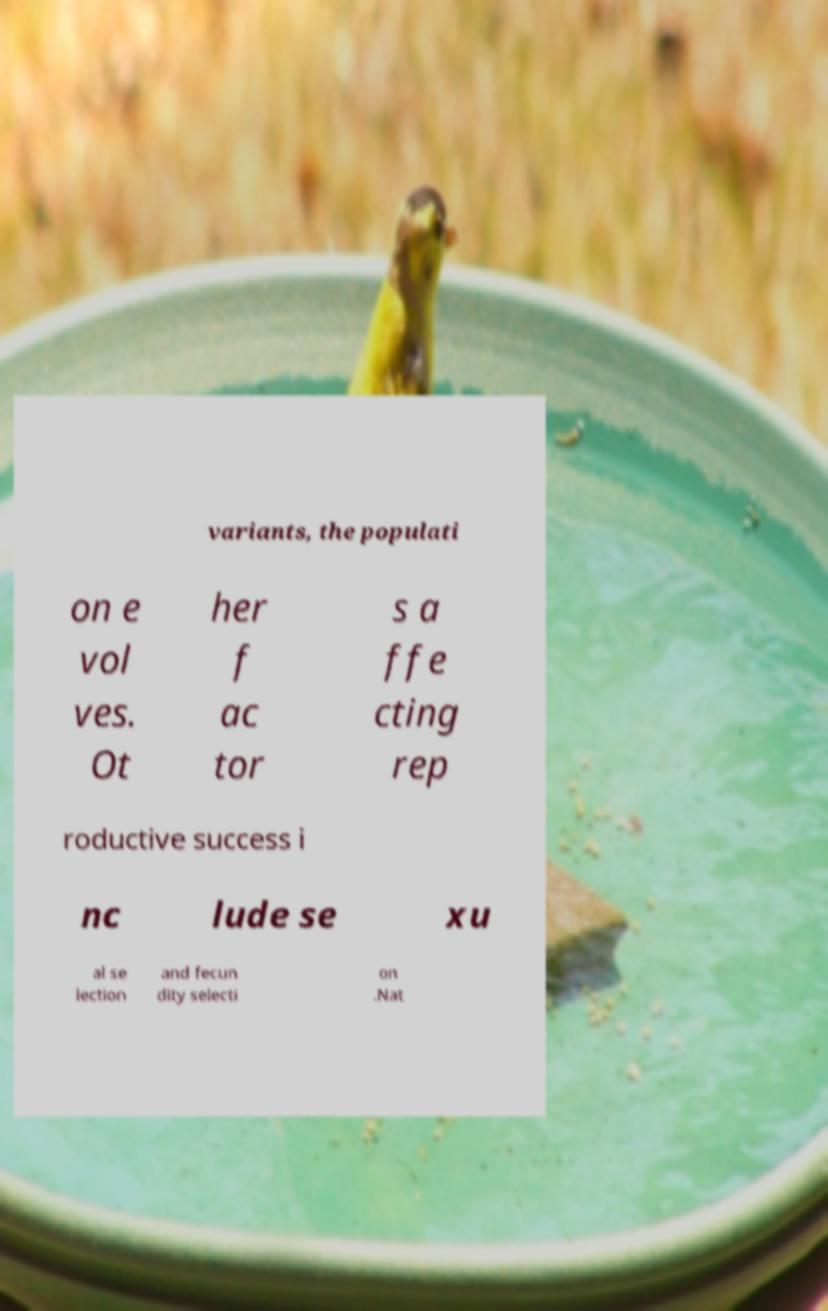Please identify and transcribe the text found in this image. variants, the populati on e vol ves. Ot her f ac tor s a ffe cting rep roductive success i nc lude se xu al se lection and fecun dity selecti on .Nat 